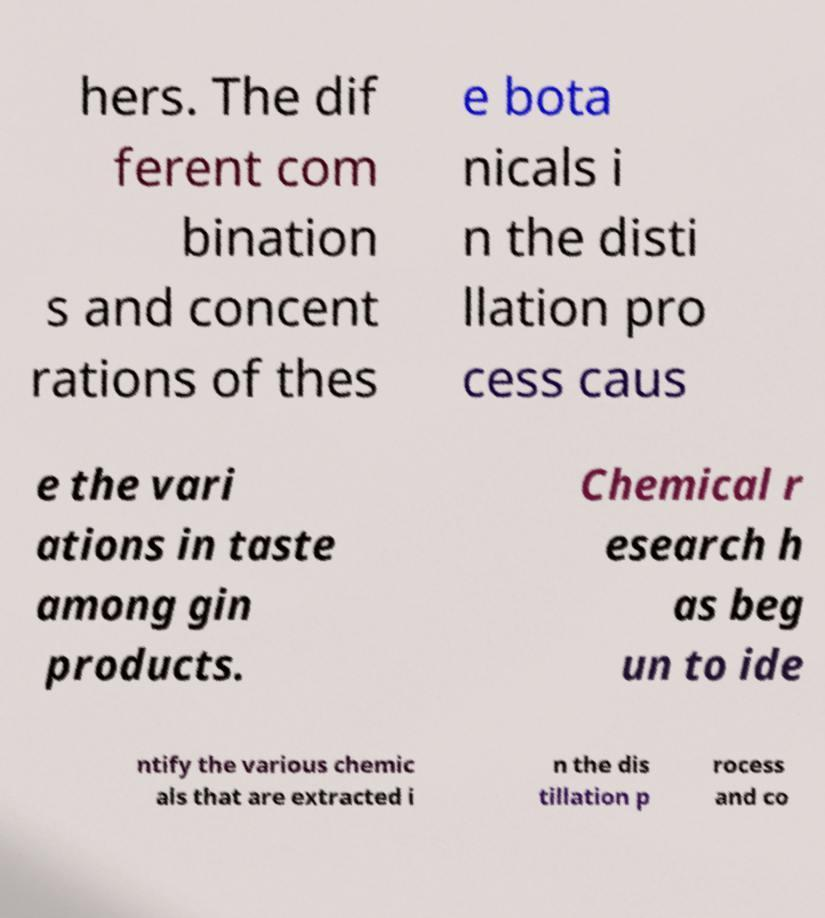Please read and relay the text visible in this image. What does it say? hers. The dif ferent com bination s and concent rations of thes e bota nicals i n the disti llation pro cess caus e the vari ations in taste among gin products. Chemical r esearch h as beg un to ide ntify the various chemic als that are extracted i n the dis tillation p rocess and co 